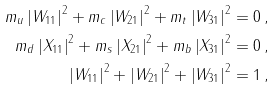Convert formula to latex. <formula><loc_0><loc_0><loc_500><loc_500>m _ { u } \left | W _ { 1 1 } \right | ^ { 2 } + m _ { c } \left | W _ { 2 1 } \right | ^ { 2 } + m _ { t } \left | W _ { 3 1 } \right | ^ { 2 } = 0 \, , \\ m _ { d } \left | X _ { 1 1 } \right | ^ { 2 } + m _ { s } \left | X _ { 2 1 } \right | ^ { 2 } + m _ { b } \left | X _ { 3 1 } \right | ^ { 2 } = 0 \, , \\ \left | W _ { 1 1 } \right | ^ { 2 } + \left | W _ { 2 1 } \right | ^ { 2 } + \left | W _ { 3 1 } \right | ^ { 2 } = 1 \, ,</formula> 